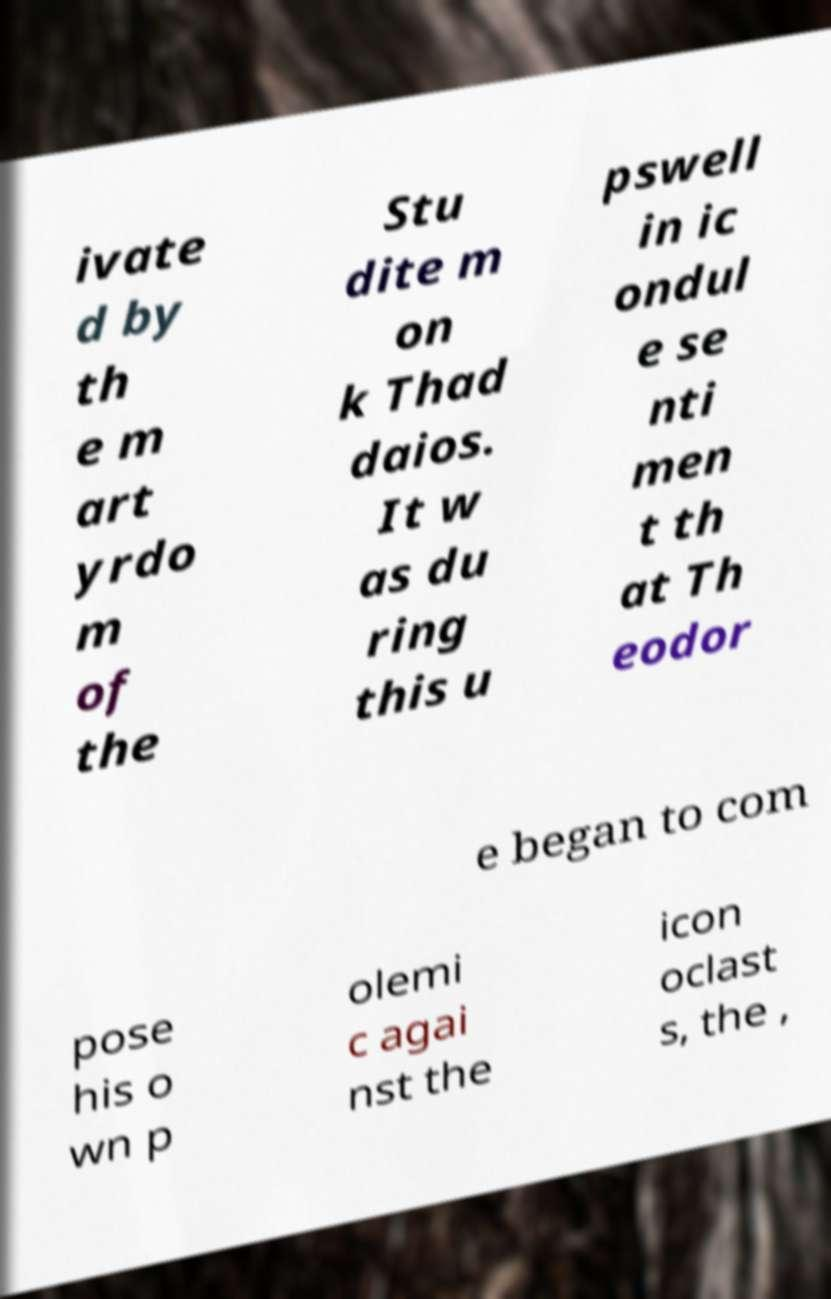Could you extract and type out the text from this image? ivate d by th e m art yrdo m of the Stu dite m on k Thad daios. It w as du ring this u pswell in ic ondul e se nti men t th at Th eodor e began to com pose his o wn p olemi c agai nst the icon oclast s, the , 